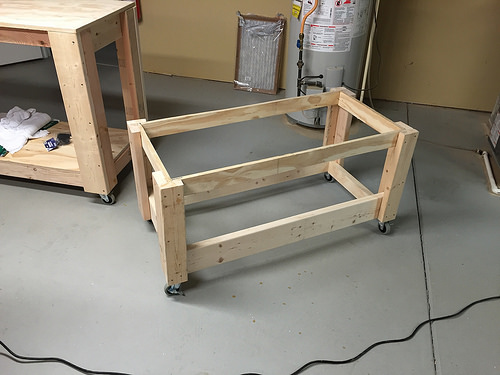<image>
Can you confirm if the table is above the cable? No. The table is not positioned above the cable. The vertical arrangement shows a different relationship. 